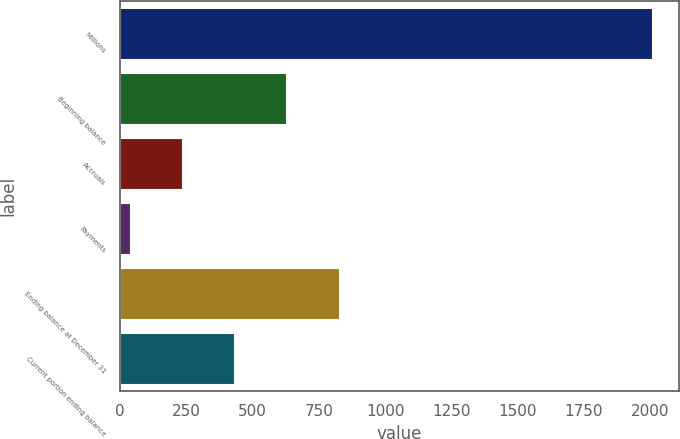Convert chart. <chart><loc_0><loc_0><loc_500><loc_500><bar_chart><fcel>Millions<fcel>Beginning balance<fcel>Accruals<fcel>Payments<fcel>Ending balance at December 31<fcel>Current portion ending balance<nl><fcel>2009<fcel>631.4<fcel>237.8<fcel>41<fcel>828.2<fcel>434.6<nl></chart> 